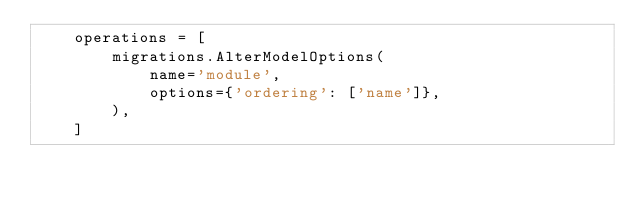<code> <loc_0><loc_0><loc_500><loc_500><_Python_>    operations = [
        migrations.AlterModelOptions(
            name='module',
            options={'ordering': ['name']},
        ),
    ]
</code> 